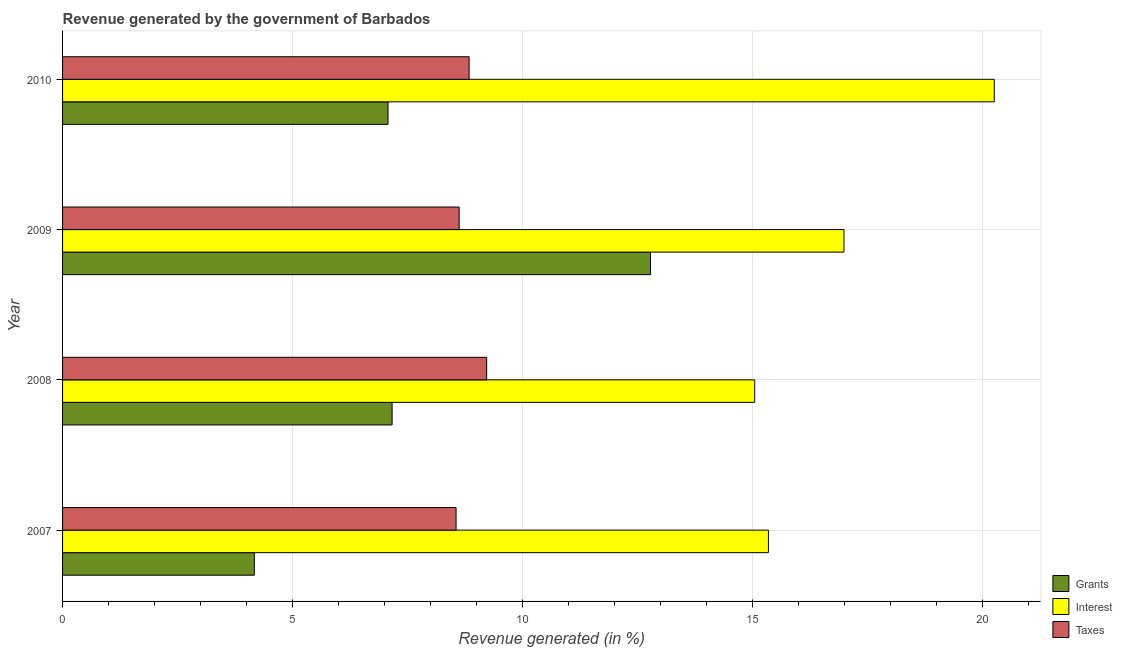How many different coloured bars are there?
Provide a succinct answer. 3. How many groups of bars are there?
Make the answer very short. 4. Are the number of bars per tick equal to the number of legend labels?
Offer a very short reply. Yes. Are the number of bars on each tick of the Y-axis equal?
Provide a short and direct response. Yes. How many bars are there on the 4th tick from the top?
Provide a succinct answer. 3. What is the label of the 4th group of bars from the top?
Make the answer very short. 2007. In how many cases, is the number of bars for a given year not equal to the number of legend labels?
Offer a very short reply. 0. What is the percentage of revenue generated by interest in 2008?
Your response must be concise. 15.06. Across all years, what is the maximum percentage of revenue generated by grants?
Offer a very short reply. 12.79. Across all years, what is the minimum percentage of revenue generated by interest?
Keep it short and to the point. 15.06. What is the total percentage of revenue generated by interest in the graph?
Ensure brevity in your answer.  67.67. What is the difference between the percentage of revenue generated by interest in 2007 and that in 2009?
Give a very brief answer. -1.64. What is the difference between the percentage of revenue generated by interest in 2010 and the percentage of revenue generated by taxes in 2009?
Provide a succinct answer. 11.64. What is the average percentage of revenue generated by taxes per year?
Ensure brevity in your answer.  8.81. In the year 2007, what is the difference between the percentage of revenue generated by grants and percentage of revenue generated by interest?
Make the answer very short. -11.18. What is the ratio of the percentage of revenue generated by taxes in 2007 to that in 2009?
Offer a very short reply. 0.99. Is the percentage of revenue generated by grants in 2008 less than that in 2009?
Your answer should be compact. Yes. Is the difference between the percentage of revenue generated by interest in 2007 and 2008 greater than the difference between the percentage of revenue generated by taxes in 2007 and 2008?
Keep it short and to the point. Yes. What is the difference between the highest and the second highest percentage of revenue generated by interest?
Your response must be concise. 3.27. What is the difference between the highest and the lowest percentage of revenue generated by interest?
Ensure brevity in your answer.  5.21. Is the sum of the percentage of revenue generated by interest in 2007 and 2009 greater than the maximum percentage of revenue generated by grants across all years?
Offer a very short reply. Yes. What does the 1st bar from the top in 2010 represents?
Provide a succinct answer. Taxes. What does the 1st bar from the bottom in 2008 represents?
Give a very brief answer. Grants. Is it the case that in every year, the sum of the percentage of revenue generated by grants and percentage of revenue generated by interest is greater than the percentage of revenue generated by taxes?
Your answer should be very brief. Yes. How many bars are there?
Provide a short and direct response. 12. What is the difference between two consecutive major ticks on the X-axis?
Provide a succinct answer. 5. Does the graph contain grids?
Provide a short and direct response. Yes. Where does the legend appear in the graph?
Your response must be concise. Bottom right. How are the legend labels stacked?
Offer a terse response. Vertical. What is the title of the graph?
Your answer should be very brief. Revenue generated by the government of Barbados. What is the label or title of the X-axis?
Ensure brevity in your answer.  Revenue generated (in %). What is the Revenue generated (in %) of Grants in 2007?
Give a very brief answer. 4.17. What is the Revenue generated (in %) in Interest in 2007?
Offer a very short reply. 15.35. What is the Revenue generated (in %) of Taxes in 2007?
Ensure brevity in your answer.  8.56. What is the Revenue generated (in %) in Grants in 2008?
Keep it short and to the point. 7.17. What is the Revenue generated (in %) of Interest in 2008?
Keep it short and to the point. 15.06. What is the Revenue generated (in %) of Taxes in 2008?
Give a very brief answer. 9.23. What is the Revenue generated (in %) in Grants in 2009?
Provide a short and direct response. 12.79. What is the Revenue generated (in %) in Interest in 2009?
Make the answer very short. 17. What is the Revenue generated (in %) of Taxes in 2009?
Offer a terse response. 8.63. What is the Revenue generated (in %) of Grants in 2010?
Your response must be concise. 7.08. What is the Revenue generated (in %) in Interest in 2010?
Make the answer very short. 20.27. What is the Revenue generated (in %) in Taxes in 2010?
Provide a short and direct response. 8.84. Across all years, what is the maximum Revenue generated (in %) of Grants?
Make the answer very short. 12.79. Across all years, what is the maximum Revenue generated (in %) of Interest?
Make the answer very short. 20.27. Across all years, what is the maximum Revenue generated (in %) of Taxes?
Provide a succinct answer. 9.23. Across all years, what is the minimum Revenue generated (in %) of Grants?
Keep it short and to the point. 4.17. Across all years, what is the minimum Revenue generated (in %) in Interest?
Offer a very short reply. 15.06. Across all years, what is the minimum Revenue generated (in %) in Taxes?
Your answer should be very brief. 8.56. What is the total Revenue generated (in %) of Grants in the graph?
Your response must be concise. 31.21. What is the total Revenue generated (in %) in Interest in the graph?
Offer a terse response. 67.67. What is the total Revenue generated (in %) in Taxes in the graph?
Provide a short and direct response. 35.25. What is the difference between the Revenue generated (in %) of Grants in 2007 and that in 2008?
Provide a short and direct response. -3. What is the difference between the Revenue generated (in %) in Interest in 2007 and that in 2008?
Your answer should be very brief. 0.3. What is the difference between the Revenue generated (in %) of Taxes in 2007 and that in 2008?
Ensure brevity in your answer.  -0.67. What is the difference between the Revenue generated (in %) in Grants in 2007 and that in 2009?
Give a very brief answer. -8.62. What is the difference between the Revenue generated (in %) in Interest in 2007 and that in 2009?
Your answer should be compact. -1.64. What is the difference between the Revenue generated (in %) in Taxes in 2007 and that in 2009?
Offer a terse response. -0.07. What is the difference between the Revenue generated (in %) of Grants in 2007 and that in 2010?
Offer a terse response. -2.91. What is the difference between the Revenue generated (in %) of Interest in 2007 and that in 2010?
Make the answer very short. -4.91. What is the difference between the Revenue generated (in %) in Taxes in 2007 and that in 2010?
Keep it short and to the point. -0.28. What is the difference between the Revenue generated (in %) of Grants in 2008 and that in 2009?
Offer a very short reply. -5.62. What is the difference between the Revenue generated (in %) in Interest in 2008 and that in 2009?
Provide a short and direct response. -1.94. What is the difference between the Revenue generated (in %) of Taxes in 2008 and that in 2009?
Keep it short and to the point. 0.6. What is the difference between the Revenue generated (in %) of Grants in 2008 and that in 2010?
Your answer should be compact. 0.09. What is the difference between the Revenue generated (in %) in Interest in 2008 and that in 2010?
Offer a very short reply. -5.21. What is the difference between the Revenue generated (in %) of Taxes in 2008 and that in 2010?
Offer a terse response. 0.38. What is the difference between the Revenue generated (in %) of Grants in 2009 and that in 2010?
Give a very brief answer. 5.71. What is the difference between the Revenue generated (in %) in Interest in 2009 and that in 2010?
Ensure brevity in your answer.  -3.27. What is the difference between the Revenue generated (in %) of Taxes in 2009 and that in 2010?
Your answer should be compact. -0.22. What is the difference between the Revenue generated (in %) of Grants in 2007 and the Revenue generated (in %) of Interest in 2008?
Your response must be concise. -10.88. What is the difference between the Revenue generated (in %) in Grants in 2007 and the Revenue generated (in %) in Taxes in 2008?
Your answer should be compact. -5.05. What is the difference between the Revenue generated (in %) in Interest in 2007 and the Revenue generated (in %) in Taxes in 2008?
Offer a terse response. 6.13. What is the difference between the Revenue generated (in %) in Grants in 2007 and the Revenue generated (in %) in Interest in 2009?
Ensure brevity in your answer.  -12.83. What is the difference between the Revenue generated (in %) in Grants in 2007 and the Revenue generated (in %) in Taxes in 2009?
Your response must be concise. -4.46. What is the difference between the Revenue generated (in %) of Interest in 2007 and the Revenue generated (in %) of Taxes in 2009?
Offer a terse response. 6.73. What is the difference between the Revenue generated (in %) of Grants in 2007 and the Revenue generated (in %) of Interest in 2010?
Your answer should be very brief. -16.1. What is the difference between the Revenue generated (in %) of Grants in 2007 and the Revenue generated (in %) of Taxes in 2010?
Provide a short and direct response. -4.67. What is the difference between the Revenue generated (in %) in Interest in 2007 and the Revenue generated (in %) in Taxes in 2010?
Give a very brief answer. 6.51. What is the difference between the Revenue generated (in %) of Grants in 2008 and the Revenue generated (in %) of Interest in 2009?
Your response must be concise. -9.83. What is the difference between the Revenue generated (in %) in Grants in 2008 and the Revenue generated (in %) in Taxes in 2009?
Keep it short and to the point. -1.46. What is the difference between the Revenue generated (in %) of Interest in 2008 and the Revenue generated (in %) of Taxes in 2009?
Provide a succinct answer. 6.43. What is the difference between the Revenue generated (in %) in Grants in 2008 and the Revenue generated (in %) in Interest in 2010?
Keep it short and to the point. -13.1. What is the difference between the Revenue generated (in %) in Grants in 2008 and the Revenue generated (in %) in Taxes in 2010?
Keep it short and to the point. -1.67. What is the difference between the Revenue generated (in %) of Interest in 2008 and the Revenue generated (in %) of Taxes in 2010?
Your response must be concise. 6.21. What is the difference between the Revenue generated (in %) in Grants in 2009 and the Revenue generated (in %) in Interest in 2010?
Provide a short and direct response. -7.48. What is the difference between the Revenue generated (in %) of Grants in 2009 and the Revenue generated (in %) of Taxes in 2010?
Give a very brief answer. 3.95. What is the difference between the Revenue generated (in %) in Interest in 2009 and the Revenue generated (in %) in Taxes in 2010?
Your response must be concise. 8.15. What is the average Revenue generated (in %) in Grants per year?
Your answer should be compact. 7.8. What is the average Revenue generated (in %) of Interest per year?
Offer a terse response. 16.92. What is the average Revenue generated (in %) of Taxes per year?
Your answer should be compact. 8.81. In the year 2007, what is the difference between the Revenue generated (in %) in Grants and Revenue generated (in %) in Interest?
Offer a terse response. -11.18. In the year 2007, what is the difference between the Revenue generated (in %) in Grants and Revenue generated (in %) in Taxes?
Provide a succinct answer. -4.39. In the year 2007, what is the difference between the Revenue generated (in %) of Interest and Revenue generated (in %) of Taxes?
Ensure brevity in your answer.  6.79. In the year 2008, what is the difference between the Revenue generated (in %) in Grants and Revenue generated (in %) in Interest?
Give a very brief answer. -7.89. In the year 2008, what is the difference between the Revenue generated (in %) in Grants and Revenue generated (in %) in Taxes?
Give a very brief answer. -2.06. In the year 2008, what is the difference between the Revenue generated (in %) in Interest and Revenue generated (in %) in Taxes?
Your response must be concise. 5.83. In the year 2009, what is the difference between the Revenue generated (in %) of Grants and Revenue generated (in %) of Interest?
Make the answer very short. -4.21. In the year 2009, what is the difference between the Revenue generated (in %) in Grants and Revenue generated (in %) in Taxes?
Provide a short and direct response. 4.16. In the year 2009, what is the difference between the Revenue generated (in %) in Interest and Revenue generated (in %) in Taxes?
Your response must be concise. 8.37. In the year 2010, what is the difference between the Revenue generated (in %) of Grants and Revenue generated (in %) of Interest?
Offer a terse response. -13.19. In the year 2010, what is the difference between the Revenue generated (in %) in Grants and Revenue generated (in %) in Taxes?
Offer a very short reply. -1.76. In the year 2010, what is the difference between the Revenue generated (in %) in Interest and Revenue generated (in %) in Taxes?
Your answer should be compact. 11.42. What is the ratio of the Revenue generated (in %) in Grants in 2007 to that in 2008?
Ensure brevity in your answer.  0.58. What is the ratio of the Revenue generated (in %) of Interest in 2007 to that in 2008?
Make the answer very short. 1.02. What is the ratio of the Revenue generated (in %) in Taxes in 2007 to that in 2008?
Give a very brief answer. 0.93. What is the ratio of the Revenue generated (in %) in Grants in 2007 to that in 2009?
Provide a short and direct response. 0.33. What is the ratio of the Revenue generated (in %) in Interest in 2007 to that in 2009?
Your response must be concise. 0.9. What is the ratio of the Revenue generated (in %) in Taxes in 2007 to that in 2009?
Offer a very short reply. 0.99. What is the ratio of the Revenue generated (in %) in Grants in 2007 to that in 2010?
Your answer should be compact. 0.59. What is the ratio of the Revenue generated (in %) in Interest in 2007 to that in 2010?
Your answer should be very brief. 0.76. What is the ratio of the Revenue generated (in %) in Taxes in 2007 to that in 2010?
Provide a short and direct response. 0.97. What is the ratio of the Revenue generated (in %) in Grants in 2008 to that in 2009?
Your response must be concise. 0.56. What is the ratio of the Revenue generated (in %) in Interest in 2008 to that in 2009?
Provide a short and direct response. 0.89. What is the ratio of the Revenue generated (in %) in Taxes in 2008 to that in 2009?
Keep it short and to the point. 1.07. What is the ratio of the Revenue generated (in %) of Grants in 2008 to that in 2010?
Make the answer very short. 1.01. What is the ratio of the Revenue generated (in %) in Interest in 2008 to that in 2010?
Your answer should be compact. 0.74. What is the ratio of the Revenue generated (in %) of Taxes in 2008 to that in 2010?
Provide a succinct answer. 1.04. What is the ratio of the Revenue generated (in %) of Grants in 2009 to that in 2010?
Ensure brevity in your answer.  1.81. What is the ratio of the Revenue generated (in %) of Interest in 2009 to that in 2010?
Your answer should be very brief. 0.84. What is the ratio of the Revenue generated (in %) of Taxes in 2009 to that in 2010?
Keep it short and to the point. 0.98. What is the difference between the highest and the second highest Revenue generated (in %) in Grants?
Provide a short and direct response. 5.62. What is the difference between the highest and the second highest Revenue generated (in %) of Interest?
Provide a succinct answer. 3.27. What is the difference between the highest and the second highest Revenue generated (in %) in Taxes?
Ensure brevity in your answer.  0.38. What is the difference between the highest and the lowest Revenue generated (in %) in Grants?
Your response must be concise. 8.62. What is the difference between the highest and the lowest Revenue generated (in %) in Interest?
Provide a short and direct response. 5.21. What is the difference between the highest and the lowest Revenue generated (in %) in Taxes?
Provide a succinct answer. 0.67. 